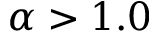<formula> <loc_0><loc_0><loc_500><loc_500>\alpha > 1 . 0</formula> 